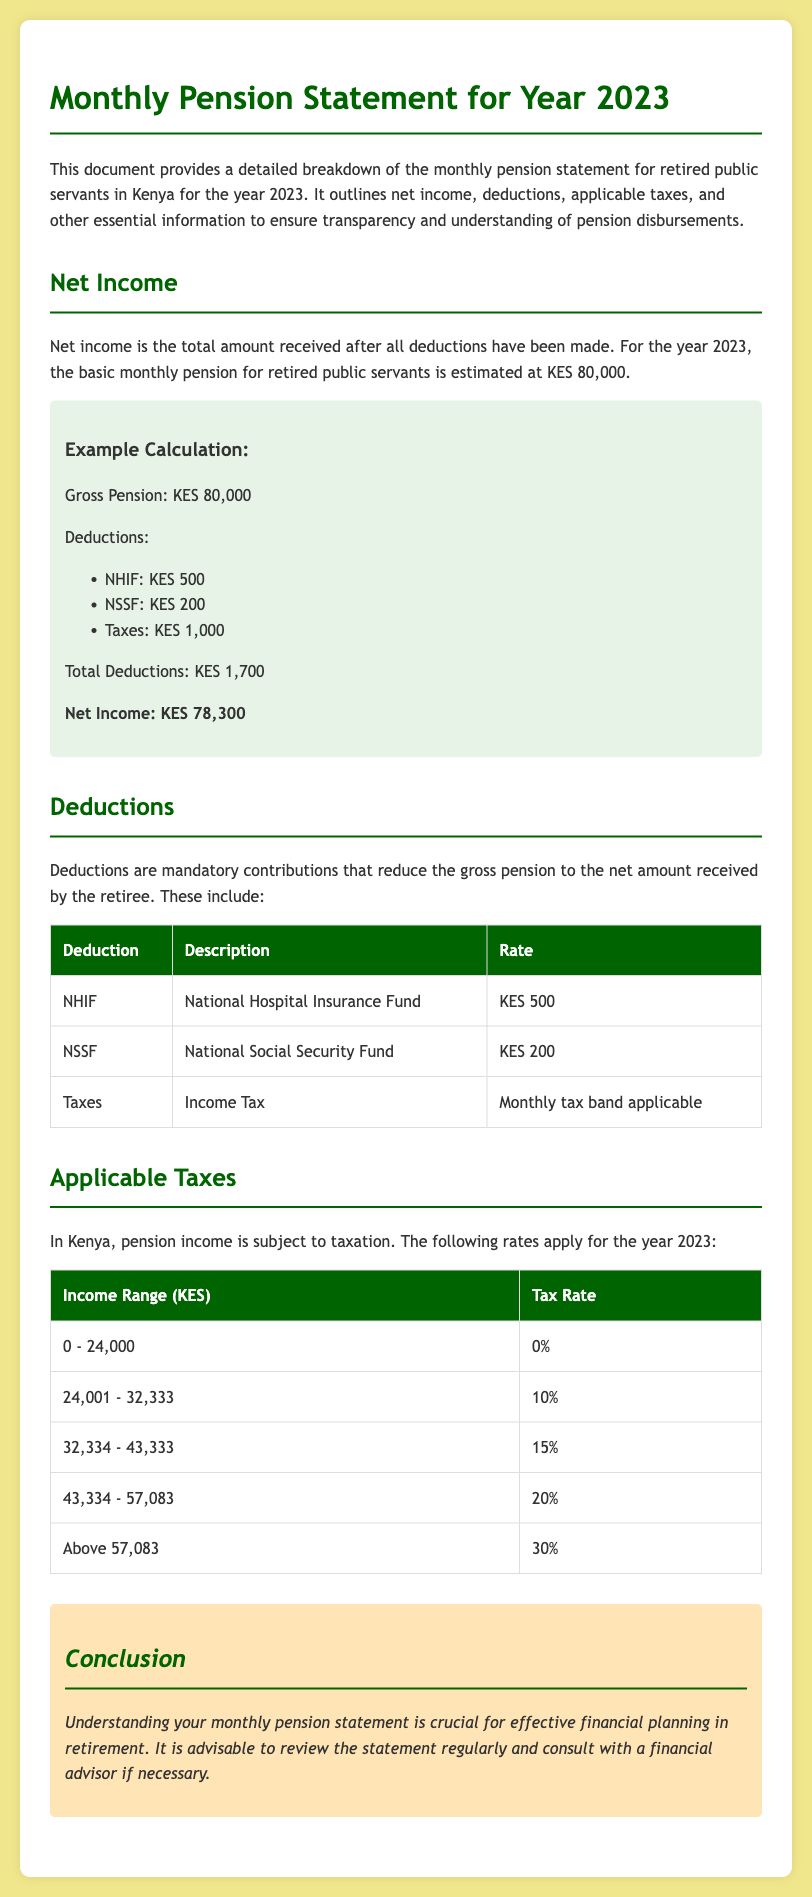What is the basic monthly pension for retired public servants? The document states that the basic monthly pension for retired public servants is KES 80,000.
Answer: KES 80,000 What is the total amount of deductions listed? The document lists NHIF, NSSF, and Taxes as deductions, totaling KES 1,700.
Answer: KES 1,700 What is the net income after deductions? The net income is calculated by subtracting the deductions from the gross pension amount, resulting in KES 78,300.
Answer: KES 78,300 What is the tax rate for the income range of 24,001 - 32,333? The document specifies that the tax rate for this income range is 10%.
Answer: 10% What is the deduction amount for NHIF? The document mentions that the NHIF deduction is KES 500.
Answer: KES 500 How much tax is deducted if the pension income is KES 50,000? For KES 50,000, the applicable tax rates indicate that 20% applies to the portion over KES 43,334. The calculated tax will need deduction based on the tax bands provided.
Answer: KES 2,766 What are the two mandatory deductions listed in the document? The document describes NHIF and NSSF as mandatory deductions reducing the gross pension.
Answer: NHIF and NSSF What is the highest tax rate applicable to pension income? The document states that the highest tax rate applicable is 30%.
Answer: 30% What does the conclusion section advise regarding the monthly pension statement? The conclusion section advises to review the statement regularly and consult with a financial advisor if necessary.
Answer: Review regularly and consult a financial advisor 